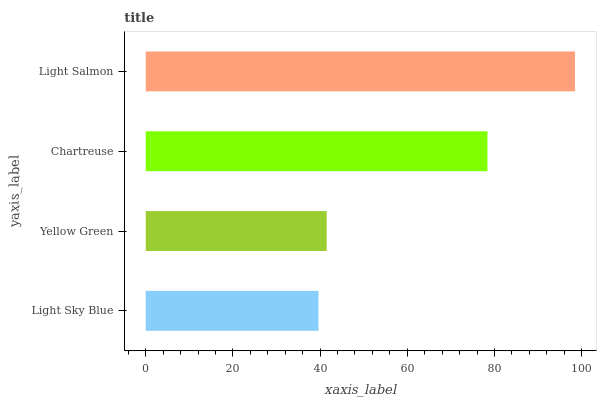Is Light Sky Blue the minimum?
Answer yes or no. Yes. Is Light Salmon the maximum?
Answer yes or no. Yes. Is Yellow Green the minimum?
Answer yes or no. No. Is Yellow Green the maximum?
Answer yes or no. No. Is Yellow Green greater than Light Sky Blue?
Answer yes or no. Yes. Is Light Sky Blue less than Yellow Green?
Answer yes or no. Yes. Is Light Sky Blue greater than Yellow Green?
Answer yes or no. No. Is Yellow Green less than Light Sky Blue?
Answer yes or no. No. Is Chartreuse the high median?
Answer yes or no. Yes. Is Yellow Green the low median?
Answer yes or no. Yes. Is Light Sky Blue the high median?
Answer yes or no. No. Is Light Salmon the low median?
Answer yes or no. No. 